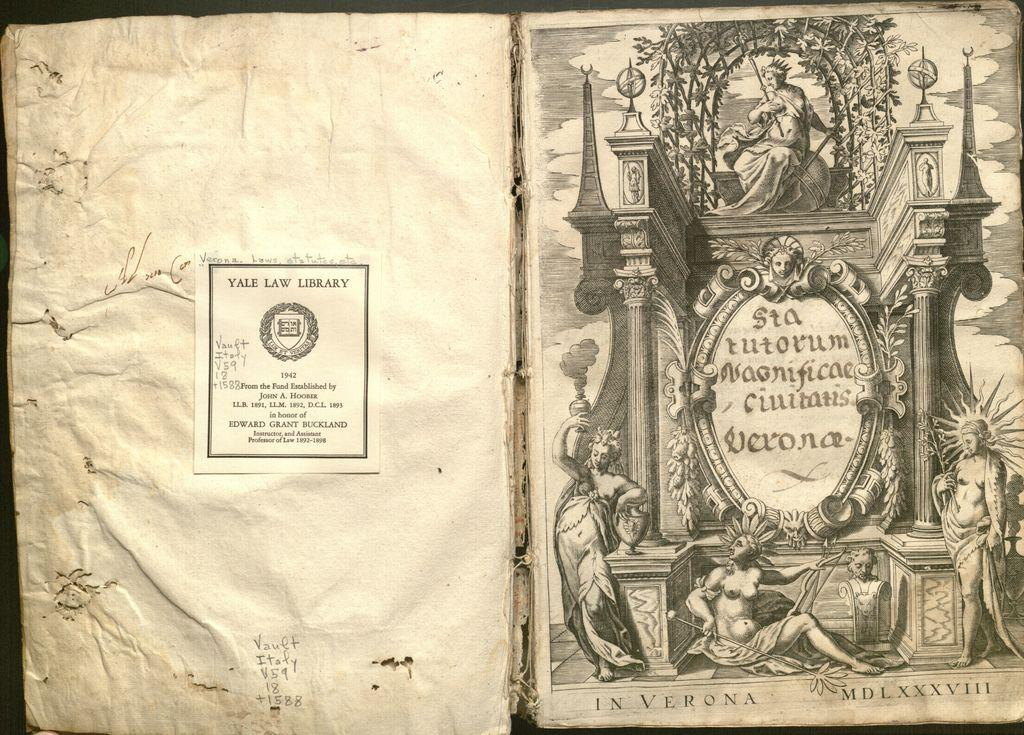<image>
Summarize the visual content of the image. An old book is in honor of Edward Grant Buckland. 